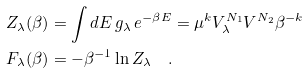Convert formula to latex. <formula><loc_0><loc_0><loc_500><loc_500>Z _ { \lambda } ( \beta ) & = \int d E \, g _ { \lambda } \, e ^ { - \beta E } = \mu ^ { k } V _ { \lambda } ^ { N _ { 1 } } V ^ { N _ { 2 } } \beta ^ { - k } \\ F _ { \lambda } ( \beta ) & = - \beta ^ { - 1 } \ln Z _ { \lambda } \quad .</formula> 